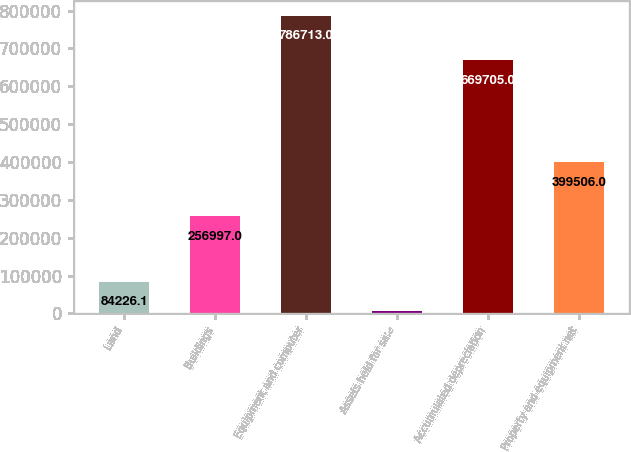Convert chart to OTSL. <chart><loc_0><loc_0><loc_500><loc_500><bar_chart><fcel>Land<fcel>Buildings<fcel>Equipment and computer<fcel>Assets held for sale<fcel>Accumulated depreciation<fcel>Property and equipment net<nl><fcel>84226.1<fcel>256997<fcel>786713<fcel>6172<fcel>669705<fcel>399506<nl></chart> 